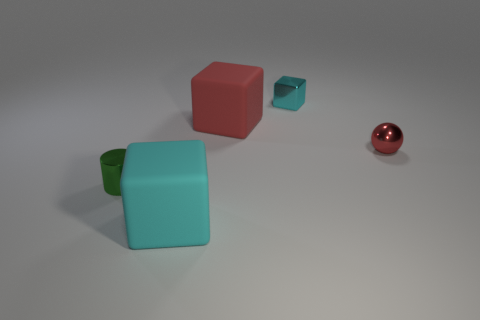Add 5 small gray things. How many objects exist? 10 Subtract all balls. How many objects are left? 4 Add 1 big red matte objects. How many big red matte objects are left? 2 Add 3 small blocks. How many small blocks exist? 4 Subtract 0 blue cylinders. How many objects are left? 5 Subtract all small red metal spheres. Subtract all green metal spheres. How many objects are left? 4 